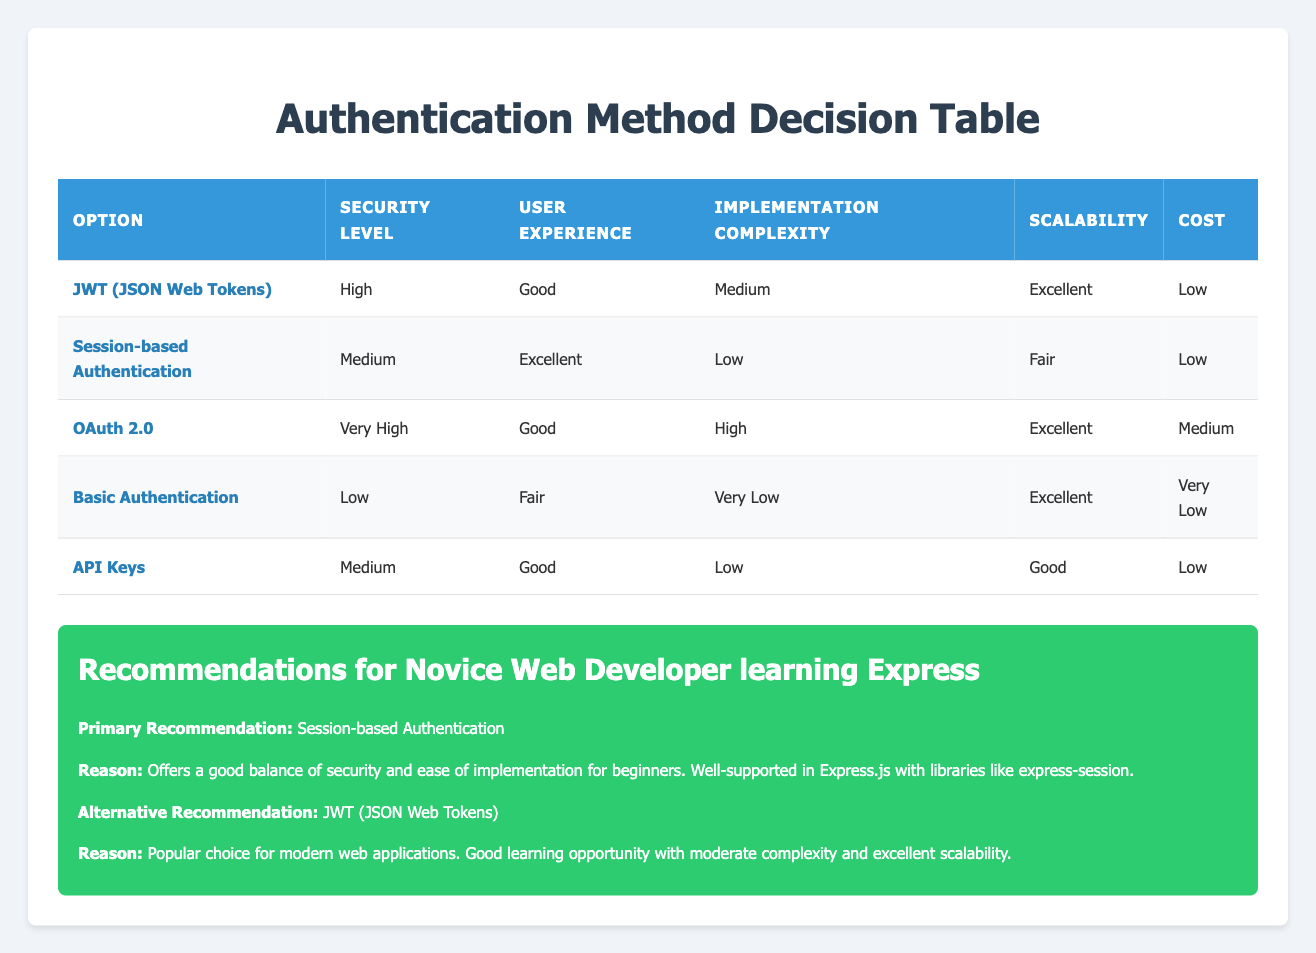What is the security level of Basic Authentication? The table indicates that Basic Authentication has a security level categorized as Low.
Answer: Low Which authentication option offers the best user experience? According to the table, Session-based Authentication offers the best user experience, rated as Excellent.
Answer: Session-based Authentication Is OAuth 2.0 more complex to implement than Session-based Authentication? The table shows that OAuth 2.0 has a High implementation complexity, while Session-based Authentication has a Low implementation complexity. Therefore, OAuth 2.0 is indeed more complex to implement.
Answer: Yes What is the cost of using JWT (JSON Web Tokens)? The table lists the cost of using JWT (JSON Web Tokens) as Low.
Answer: Low Which authentication option has the highest security level? In the table, OAuth 2.0 is listed with the highest security level rated as Very High.
Answer: OAuth 2.0 If we consider scalability, which two options are rated equally? The scale of the table shows that Basic Authentication and OAuth 2.0 both have an Excellent scalability rating.
Answer: Basic Authentication and OAuth 2.0 How does the implementation complexity of API Keys compare to Basic Authentication? API Keys have a Low implementation complexity as listed in the table, while Basic Authentication has a Very Low implementation complexity. Since Low is higher than Very Low, API Keys are slightly more complex to implement than Basic Authentication.
Answer: API Keys are more complex to implement What is the average security level among all options? The security levels are High (JWT), Medium (Session), Very High (OAuth), Low (Basic), and Medium (API Keys). Converting these into a numerical scale (Very High = 4, High = 3, Medium = 2, Low = 1), we have: (3 + 2 + 4 + 1 + 2) = 12. There are five options, so the average is 12/5 = 2.4. This means the average security level is slightly above Medium.
Answer: Above Medium Which option should a novice web developer choose for authentication? The recommendations specify that a novice web developer learning Express is advised to choose Session-based Authentication for its balance of security and ease of implementation, followed by JWT for its modern usage in web applications.
Answer: Session-based Authentication (primary), JWT (alternative) 